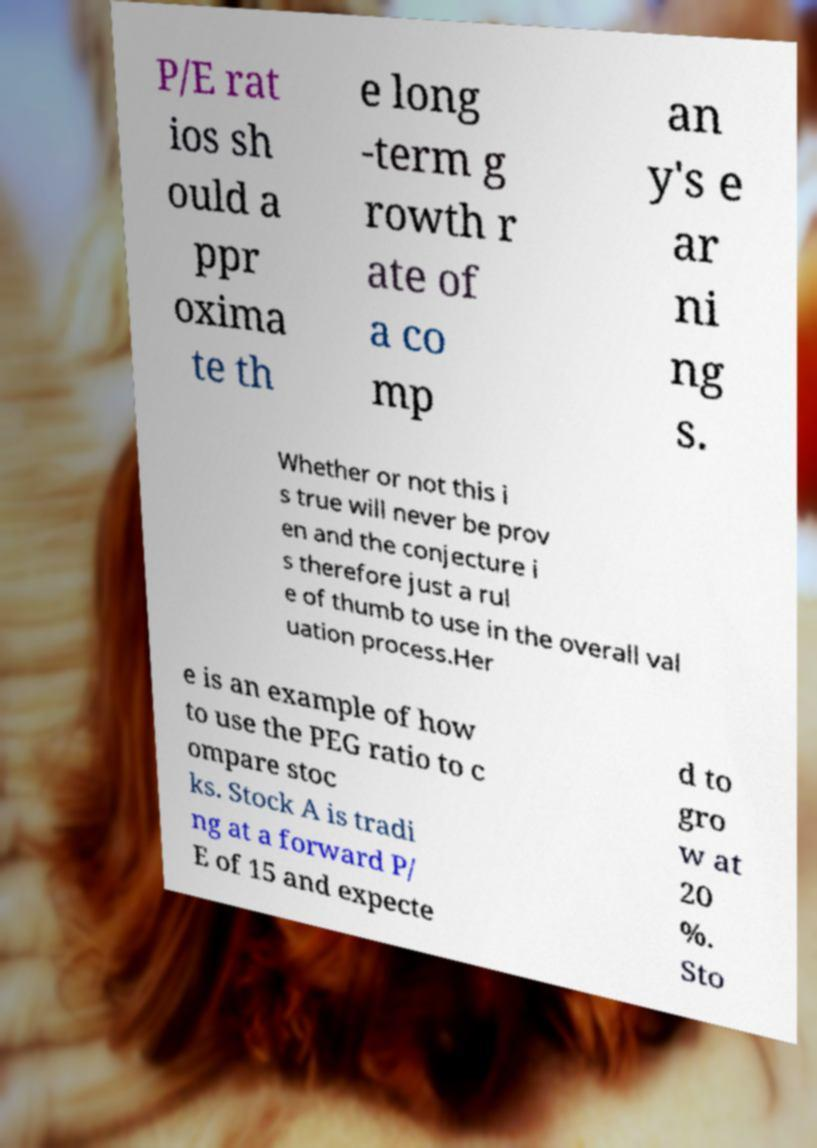Please identify and transcribe the text found in this image. P/E rat ios sh ould a ppr oxima te th e long -term g rowth r ate of a co mp an y's e ar ni ng s. Whether or not this i s true will never be prov en and the conjecture i s therefore just a rul e of thumb to use in the overall val uation process.Her e is an example of how to use the PEG ratio to c ompare stoc ks. Stock A is tradi ng at a forward P/ E of 15 and expecte d to gro w at 20 %. Sto 